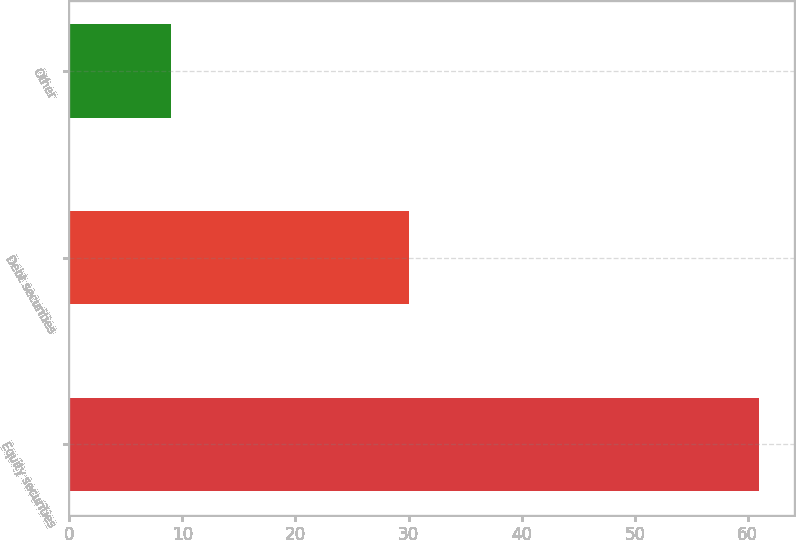Convert chart to OTSL. <chart><loc_0><loc_0><loc_500><loc_500><bar_chart><fcel>Equity securities<fcel>Debt securities<fcel>Other<nl><fcel>61<fcel>30<fcel>9<nl></chart> 